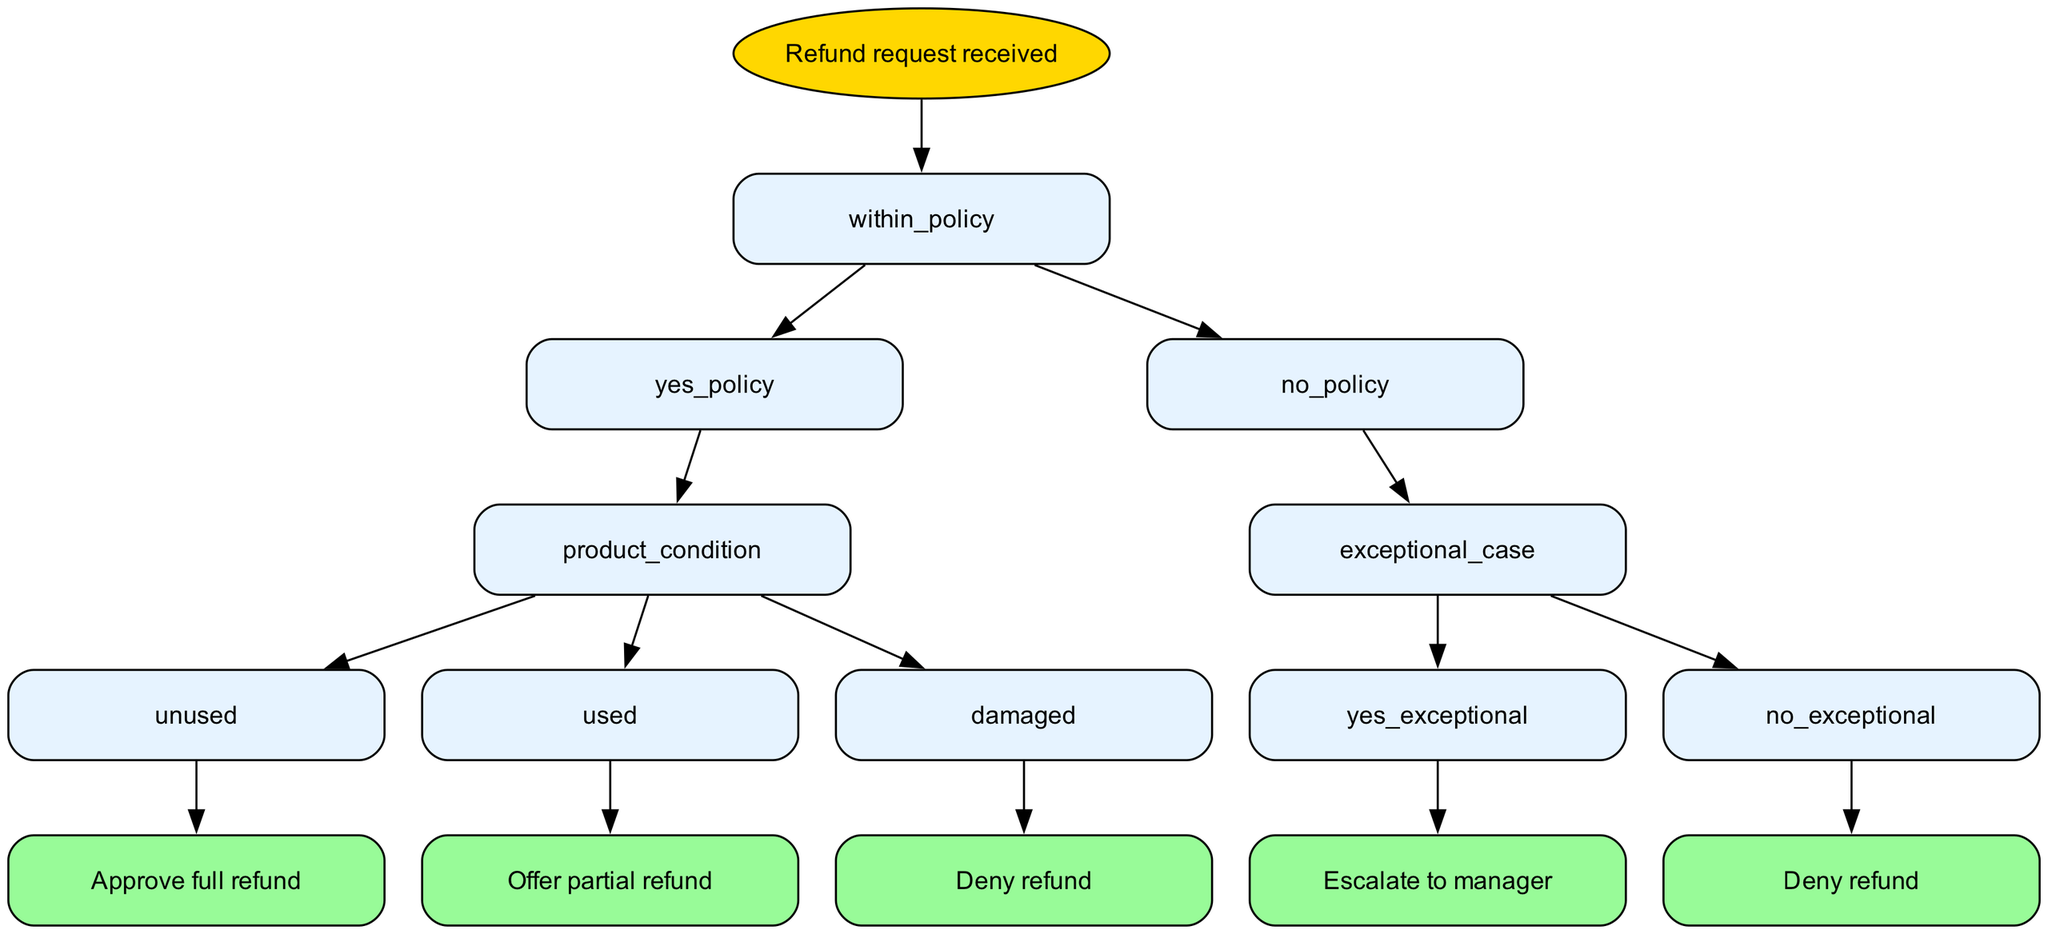What is the root node of the decision tree? The root node is the starting point of the decision tree and is labeled as "Refund request received."
Answer: Refund request received How many distinct outcomes can arise from a request within the refund policy? From a request that is within the refund policy, we can have three distinct outcomes based on product condition: "Approve full refund," "Offer partial refund," or "Deny refund."
Answer: Three What happens if the refund request is not within policy and there's no exceptional case? If the request is not within the refund policy and there is no exceptional case, the outcome is "Deny refund."
Answer: Deny refund What decision is made if the product is used? If the product is used, the decision is to "Offer partial refund."
Answer: Offer partial refund What is the action taken if a refund request is submitted for a damaged product and the damage is the customer's fault? The action taken in this case is to "Deny refund," as the customer is at fault for the damage.
Answer: Deny refund How many children does the "No" node have? The "No" node, which represents requests not within the refund policy, has one child node called "Exceptional case."
Answer: One What is the final action taken in the case of an exceptional circumstance? If there is an exceptional circumstance, the final action is to "Escalate to manager."
Answer: Escalate to manager Which decision is associated with a product that is unused? The decision associated with an unused product is to "Approve full refund."
Answer: Approve full refund What flow is followed if the request is within the refund policy but the product is damaged? If the request is within policy and the product is damaged, it leads to "Deny refund" if the customer is at fault.
Answer: Deny refund 